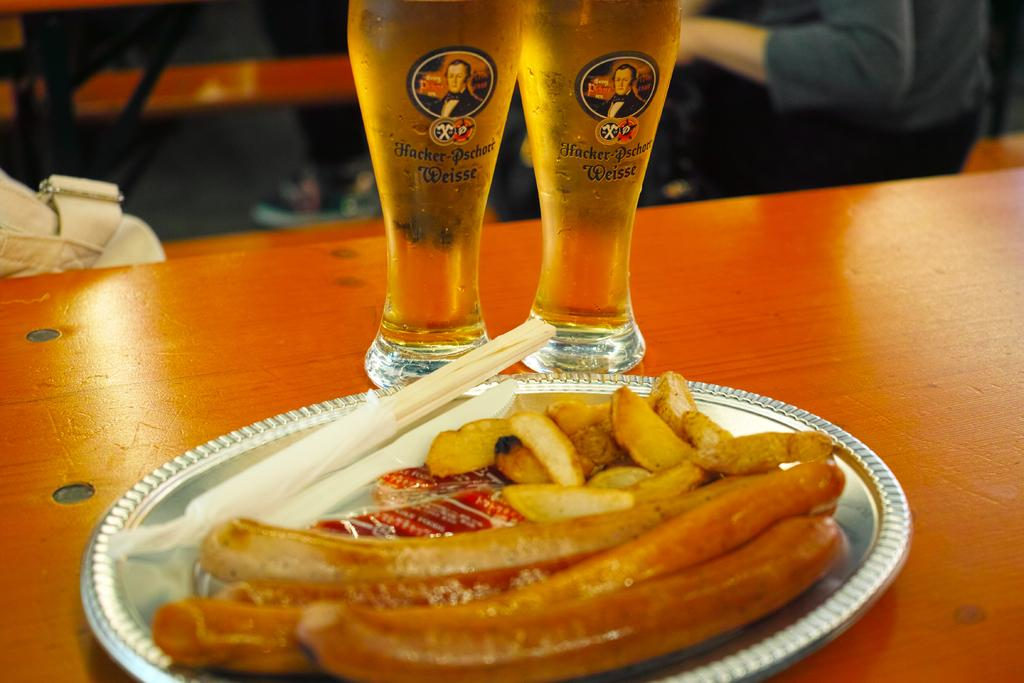What is on the plate that is visible in the image? There is food in a plate in the image. What else can be seen on the table in the image? There are glasses on the table in the image. Can you describe the human visible in the background of the image? There is a human visible in the background of the image, but no specific details are provided. What is located on the left side of the image? There is a bag on the left side of the image. What type of butter is being used to eat the food in the image? There is no butter present in the image. What advice does the dad in the image give to the person eating the food? There is no dad or advice-giving in the image. What utensil is being used to eat the food in the image? Although a fork might be a common utensil for eating food, the provided facts do not mention a fork or any specific utensil being used. 